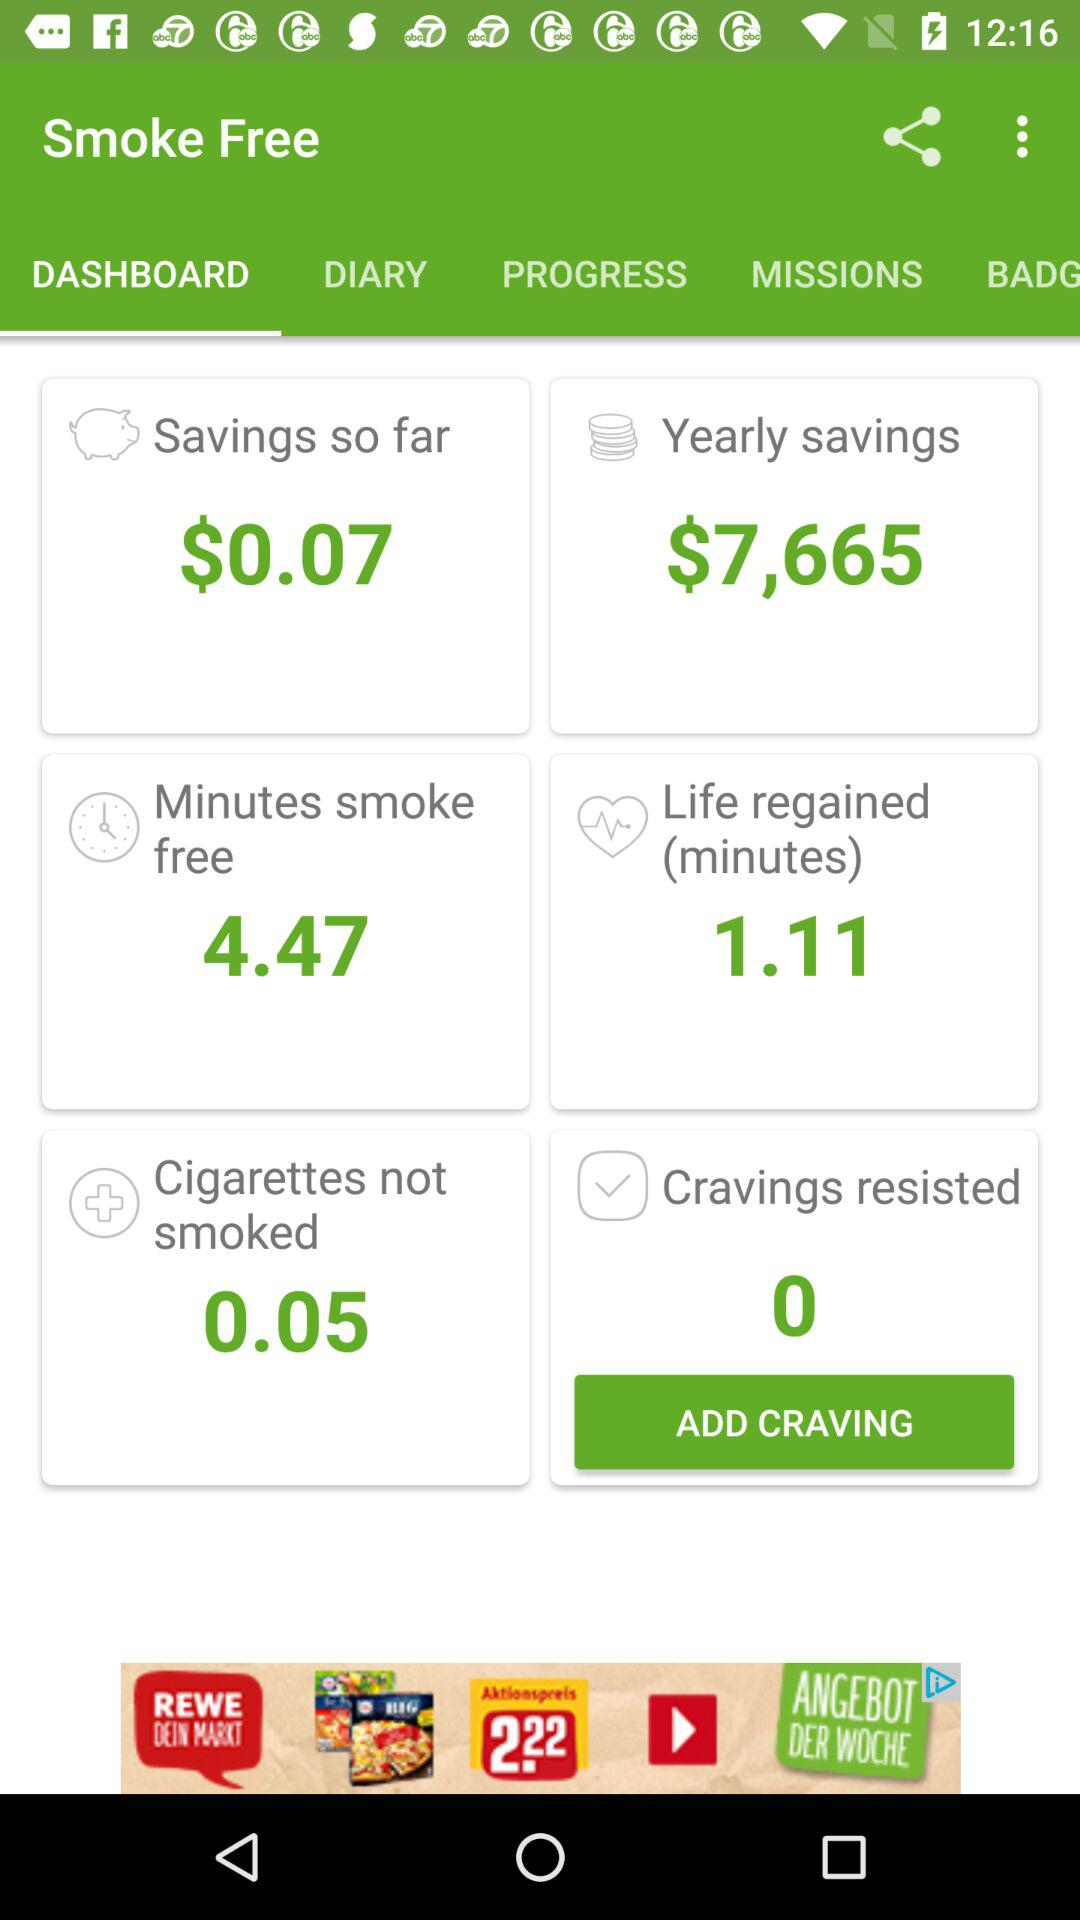What is the count for resisted cravings? The count is 0. 